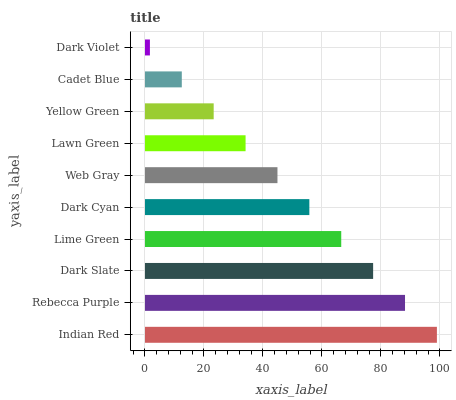Is Dark Violet the minimum?
Answer yes or no. Yes. Is Indian Red the maximum?
Answer yes or no. Yes. Is Rebecca Purple the minimum?
Answer yes or no. No. Is Rebecca Purple the maximum?
Answer yes or no. No. Is Indian Red greater than Rebecca Purple?
Answer yes or no. Yes. Is Rebecca Purple less than Indian Red?
Answer yes or no. Yes. Is Rebecca Purple greater than Indian Red?
Answer yes or no. No. Is Indian Red less than Rebecca Purple?
Answer yes or no. No. Is Dark Cyan the high median?
Answer yes or no. Yes. Is Web Gray the low median?
Answer yes or no. Yes. Is Indian Red the high median?
Answer yes or no. No. Is Dark Cyan the low median?
Answer yes or no. No. 